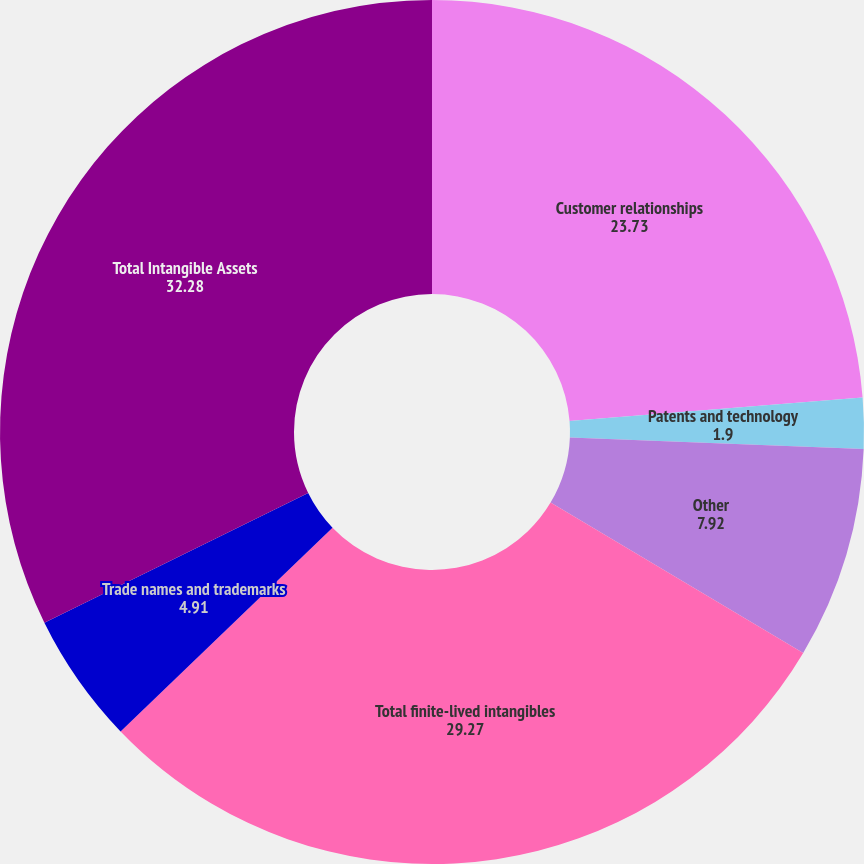<chart> <loc_0><loc_0><loc_500><loc_500><pie_chart><fcel>Customer relationships<fcel>Patents and technology<fcel>Other<fcel>Total finite-lived intangibles<fcel>Trade names and trademarks<fcel>Total Intangible Assets<nl><fcel>23.73%<fcel>1.9%<fcel>7.92%<fcel>29.27%<fcel>4.91%<fcel>32.28%<nl></chart> 